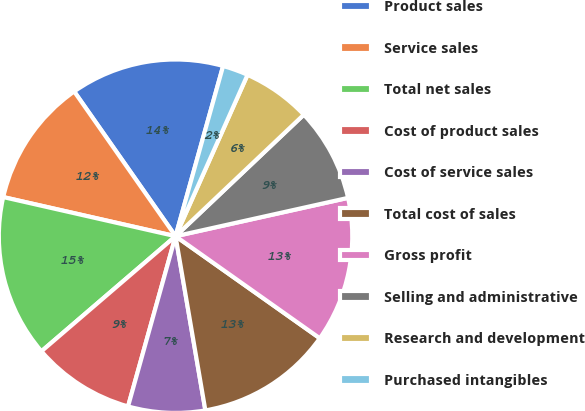Convert chart. <chart><loc_0><loc_0><loc_500><loc_500><pie_chart><fcel>Product sales<fcel>Service sales<fcel>Total net sales<fcel>Cost of product sales<fcel>Cost of service sales<fcel>Total cost of sales<fcel>Gross profit<fcel>Selling and administrative<fcel>Research and development<fcel>Purchased intangibles<nl><fcel>14.06%<fcel>11.72%<fcel>14.84%<fcel>9.38%<fcel>7.03%<fcel>12.5%<fcel>13.28%<fcel>8.59%<fcel>6.25%<fcel>2.34%<nl></chart> 